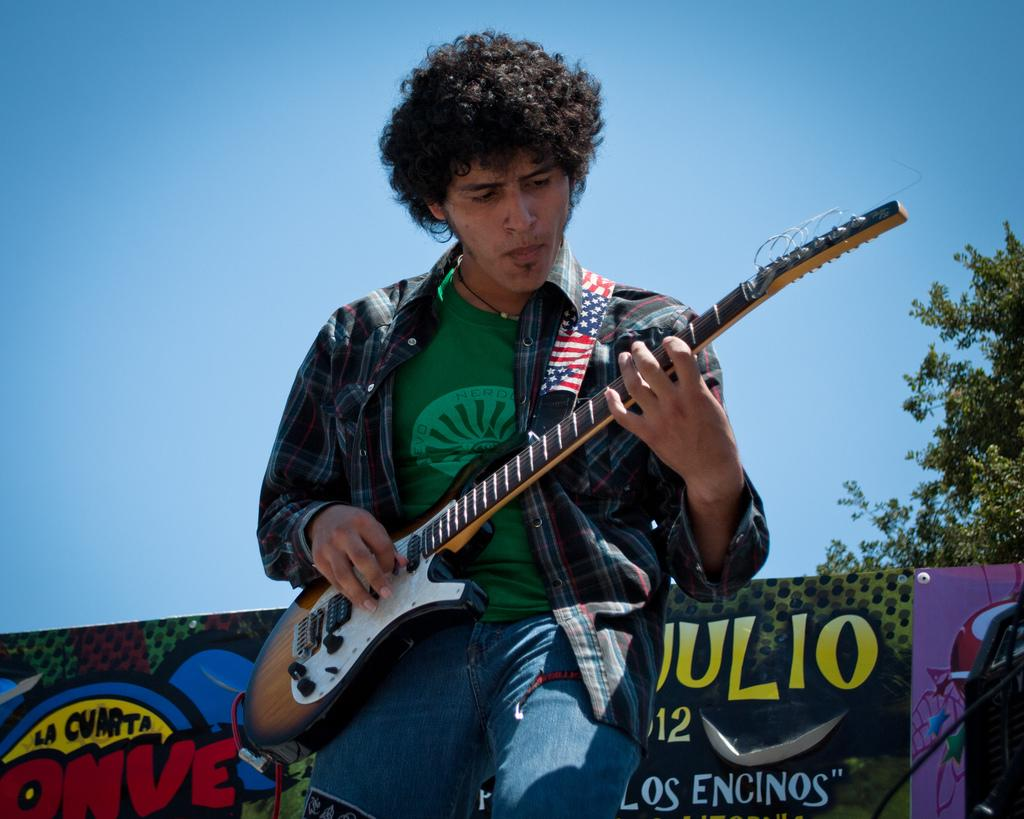What is the main subject of the image? There is a man in the center of the image. What is the man doing in the image? The man is playing a guitar. What color is the shirt the man is wearing? The man is wearing a green shirt. What can be seen in the background of the image? There is a board and a tree in the background of the image, as well as the sky. What type of roof can be seen on the board in the image? There is no roof present in the image; the board is a flat surface with no roof visible. 